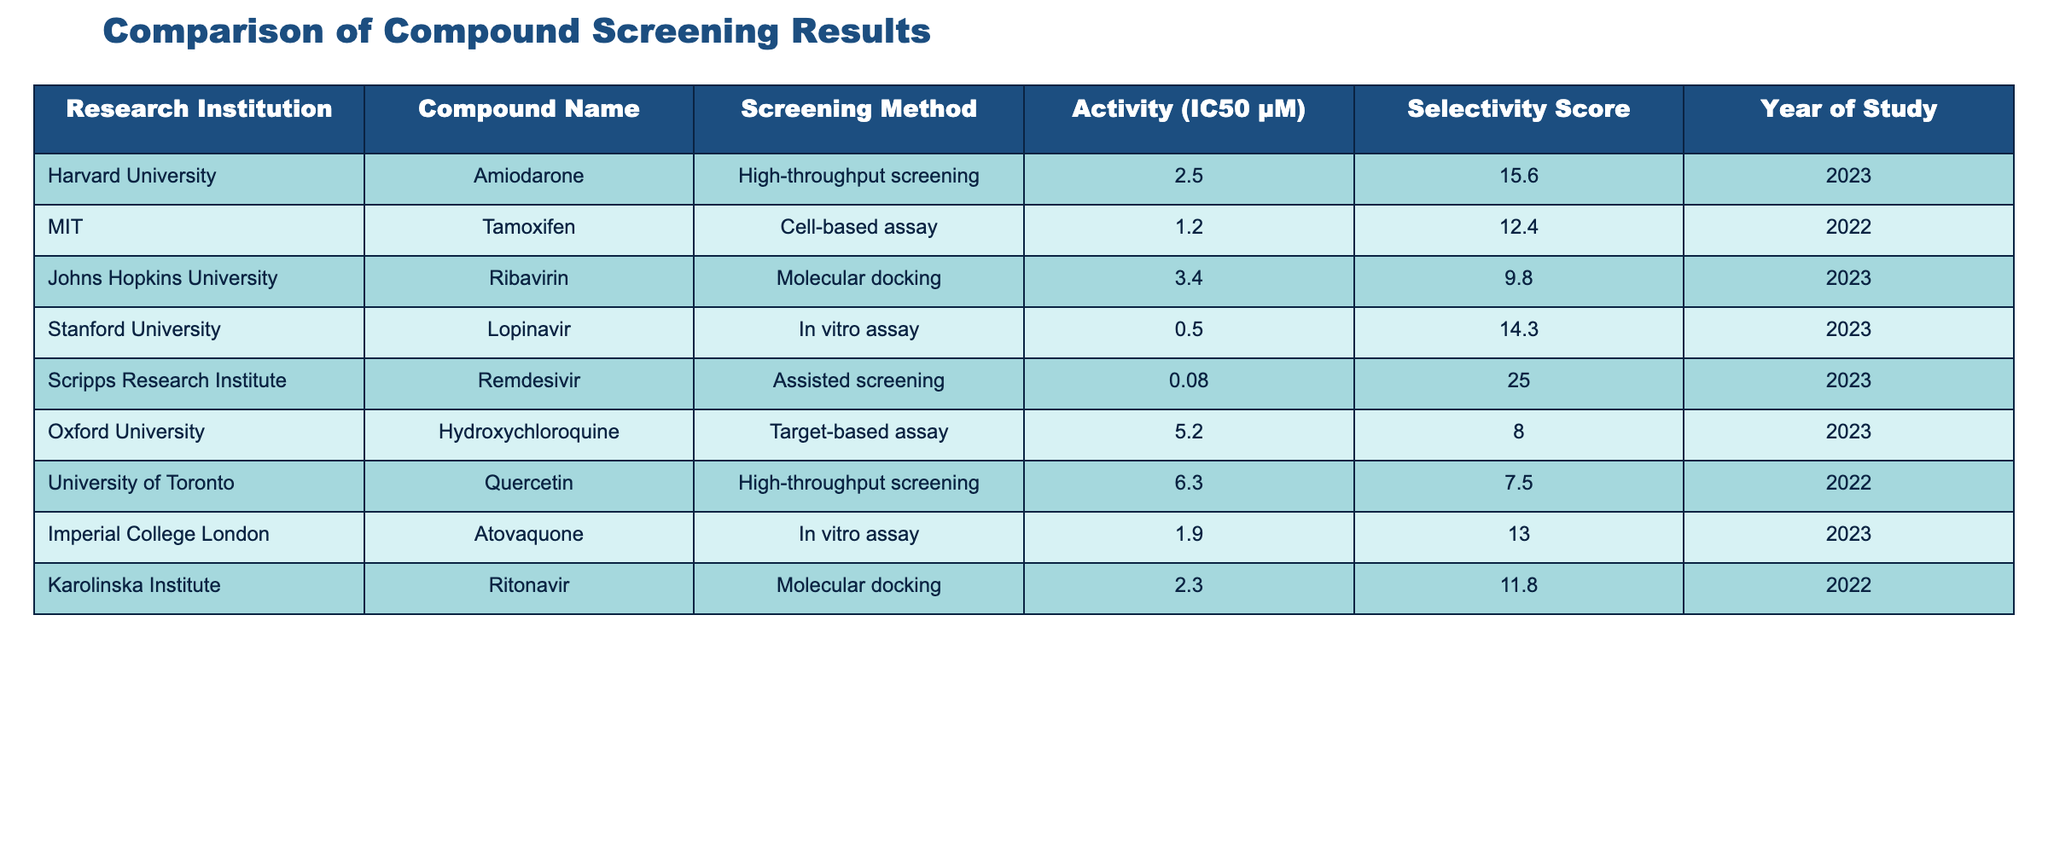What is the activity (IC50 μM) of Amiodarone? The table lists Amiodarone under the compound name from Harvard University with an activity value of 2.5 μM.
Answer: 2.5 Which compound from Stanford University has the highest selectivity score? The table indicates that Lopinavir from Stanford University has a selectivity score of 14.3, which is the highest among the compounds listed.
Answer: Lopinavir What is the average activity (IC50 μM) of the compounds tested in 2023? The compounds tested in 2023 with their IC50 values are Amiodarone (2.5), Ribavirin (3.4), Lopinavir (0.5), Remdesivir (0.08), and Hydroxychloroquine (5.2). The average is calculated as (2.5 + 3.4 + 0.5 + 0.08 + 5.2) / 5 = 11.68 / 5 = 2.336 μM.
Answer: 2.336 Did any compound from MIT report an IC50 value below 2 μM? The only compound listed from MIT is Tamoxifen with an IC50 value of 1.2 μM, which is below 2 μM.
Answer: Yes Which institution had the compound with the lowest recorded activity (IC50 μM)? The table shows Remdesivir from the Scripps Research Institute with the lowest IC50 value of 0.08 μM, which is compared to all other listed compounds.
Answer: Scripps Research Institute What is the total selectivity score of all the compounds screened by Harvard University and Johns Hopkins University? Harvard's selectivity score for Amiodarone is 15.6, and Johns Hopkins University's Ribavirin has a selectivity score of 9.8. The total is calculated as 15.6 + 9.8 = 25.4.
Answer: 25.4 Which compounds have an IC50 value greater than 5 μM and their corresponding institutions? The compound Hydroxychloroquine has an IC50 value of 5.2 μM from Oxford University and Quercetin has an IC50 value of 6.3 μM from the University of Toronto. Both are greater than 5 μM.
Answer: Hydroxychloroquine (Oxford University), Quercetin (University of Toronto) Is the selectivity score of Ribavirin higher than that of Tamoxifen? The selectivity score for Ribavirin is 9.8, whereas for Tamoxifen it is 12.4, so Ribavirin's selectivity score is not higher.
Answer: No What is the maximum IC50 value recorded for any compound screened in 2022? The only compounds screened in 2022 are Tamoxifen (1.2 μM) and Ritonavir (2.3 μM). Thus, the maximum value is 2.3 μM, recorded for Ritonavir from Karolinska Institute.
Answer: 2.3 